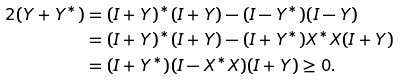<formula> <loc_0><loc_0><loc_500><loc_500>2 ( Y + Y ^ { * } ) & = ( I + Y ) ^ { * } ( I + Y ) - ( I - Y ^ { * } ) ( I - Y ) \\ & = ( I + Y ) ^ { * } ( I + Y ) - ( I + Y ^ { * } ) X ^ { * } X ( I + Y ) \\ & = ( I + Y ^ { * } ) ( I - X ^ { * } X ) ( I + Y ) \geq 0 .</formula> 